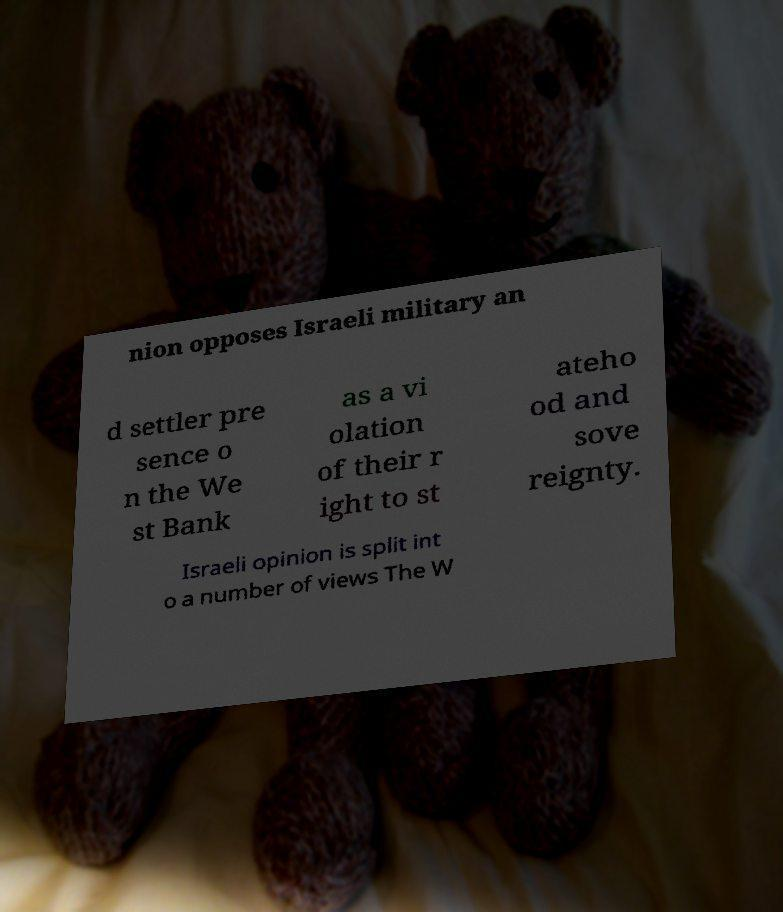For documentation purposes, I need the text within this image transcribed. Could you provide that? nion opposes Israeli military an d settler pre sence o n the We st Bank as a vi olation of their r ight to st ateho od and sove reignty. Israeli opinion is split int o a number of views The W 